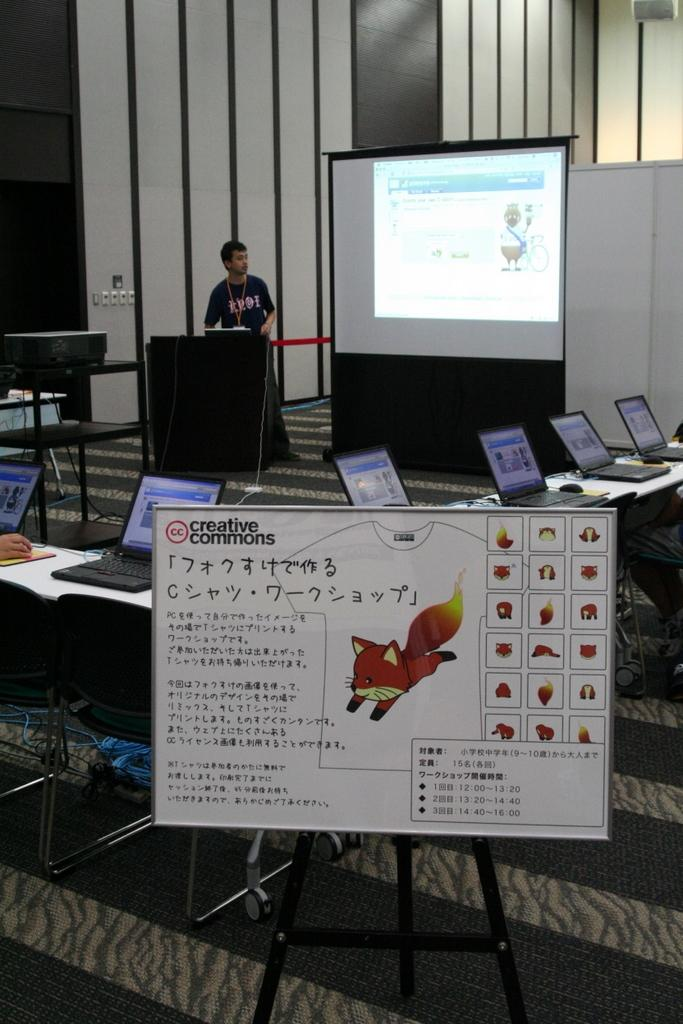What is the main object in the image? There is a board in the image. What can be seen on the table in the image? There are many laptops on a table in the image. Can you describe the person in the background of the image? There is a person standing in front of a screen in the background of the image. What type of cracker is being used to fix the laptops in the image? There is no cracker present in the image, and no laptops are being fixed. 